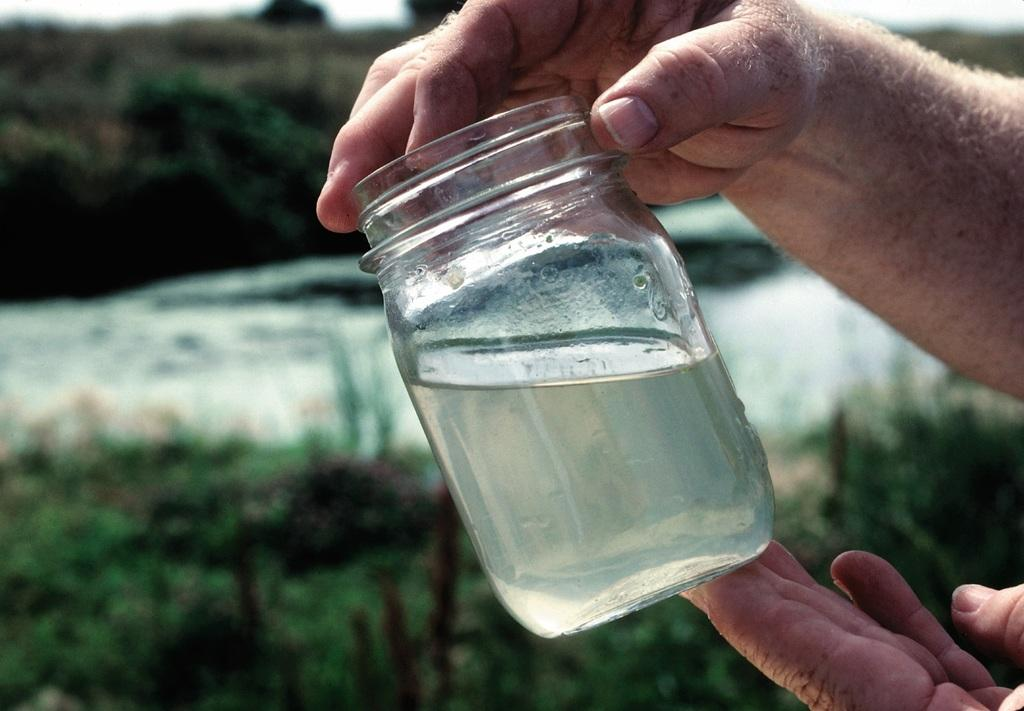What is being held by the persons' hands in the image? There are persons' hands holding a jar in the image. What is inside the jar? The jar contains water. What can be seen in the background of the image? There are trees in the background of the image. Where is the station located in the image? There is no station present in the image. Can you tell me how many aunts are visible in the image? There are no aunts visible in the image. 